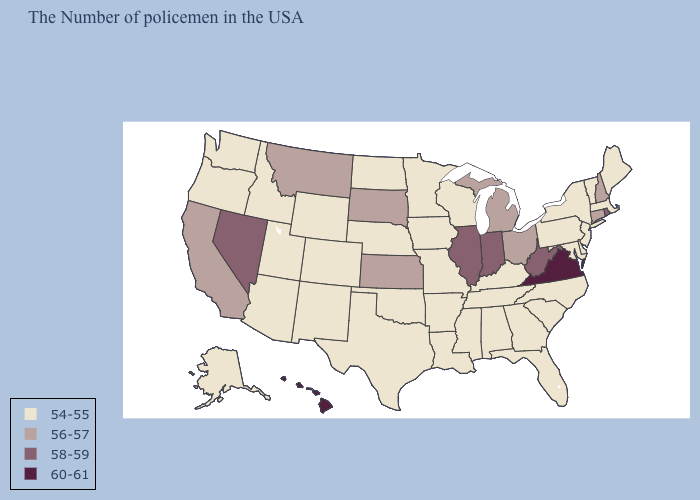What is the highest value in the MidWest ?
Quick response, please. 58-59. Among the states that border Oregon , does Nevada have the highest value?
Quick response, please. Yes. Name the states that have a value in the range 54-55?
Concise answer only. Maine, Massachusetts, Vermont, New York, New Jersey, Delaware, Maryland, Pennsylvania, North Carolina, South Carolina, Florida, Georgia, Kentucky, Alabama, Tennessee, Wisconsin, Mississippi, Louisiana, Missouri, Arkansas, Minnesota, Iowa, Nebraska, Oklahoma, Texas, North Dakota, Wyoming, Colorado, New Mexico, Utah, Arizona, Idaho, Washington, Oregon, Alaska. Does West Virginia have the lowest value in the South?
Be succinct. No. Among the states that border Montana , does South Dakota have the lowest value?
Keep it brief. No. Name the states that have a value in the range 58-59?
Answer briefly. Rhode Island, West Virginia, Indiana, Illinois, Nevada. Does New Jersey have the same value as Minnesota?
Short answer required. Yes. Name the states that have a value in the range 56-57?
Quick response, please. New Hampshire, Connecticut, Ohio, Michigan, Kansas, South Dakota, Montana, California. What is the value of Alaska?
Short answer required. 54-55. Is the legend a continuous bar?
Be succinct. No. Name the states that have a value in the range 54-55?
Short answer required. Maine, Massachusetts, Vermont, New York, New Jersey, Delaware, Maryland, Pennsylvania, North Carolina, South Carolina, Florida, Georgia, Kentucky, Alabama, Tennessee, Wisconsin, Mississippi, Louisiana, Missouri, Arkansas, Minnesota, Iowa, Nebraska, Oklahoma, Texas, North Dakota, Wyoming, Colorado, New Mexico, Utah, Arizona, Idaho, Washington, Oregon, Alaska. Does Ohio have the lowest value in the MidWest?
Give a very brief answer. No. What is the value of Mississippi?
Quick response, please. 54-55. Among the states that border Missouri , which have the highest value?
Short answer required. Illinois. What is the highest value in states that border Idaho?
Give a very brief answer. 58-59. 